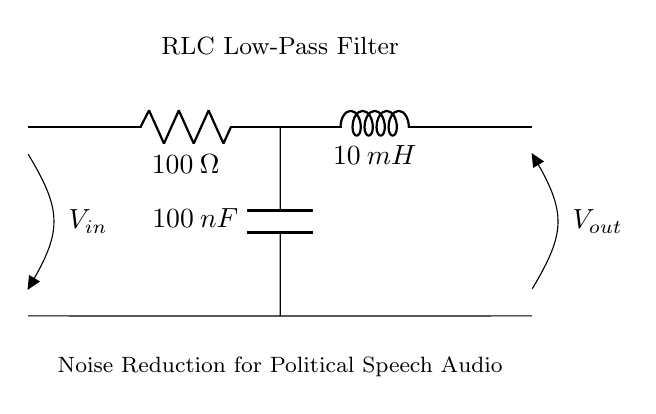What components are in this circuit? The circuit contains a resistor, an inductor, and a capacitor. These are the fundamental components of an RLC circuit.
Answer: Resistor, Inductor, Capacitor What is the resistance value in this circuit? The resistance value is specified next to the resistor symbol in the circuit, which is 100 ohms.
Answer: 100 ohms What is the inductance value in this circuit? The inductance value is specified next to the inductor symbol in the circuit, which is 10 milliHenries.
Answer: 10 milliHenries What is the capacitance value in this circuit? The capacitance value is indicated next to the capacitor symbol in the circuit, which is 100 nanoFarads.
Answer: 100 nanoFarads How does this circuit minimize noise in audio recordings? This RLC low-pass filter allows low-frequency audio signals to pass while attenuating higher-frequency noise. The resistor, inductor, and capacitor work together to filter out unwanted noise, making it ideal for political speech applications.
Answer: By allowing low frequencies to pass and attenuating high frequencies 